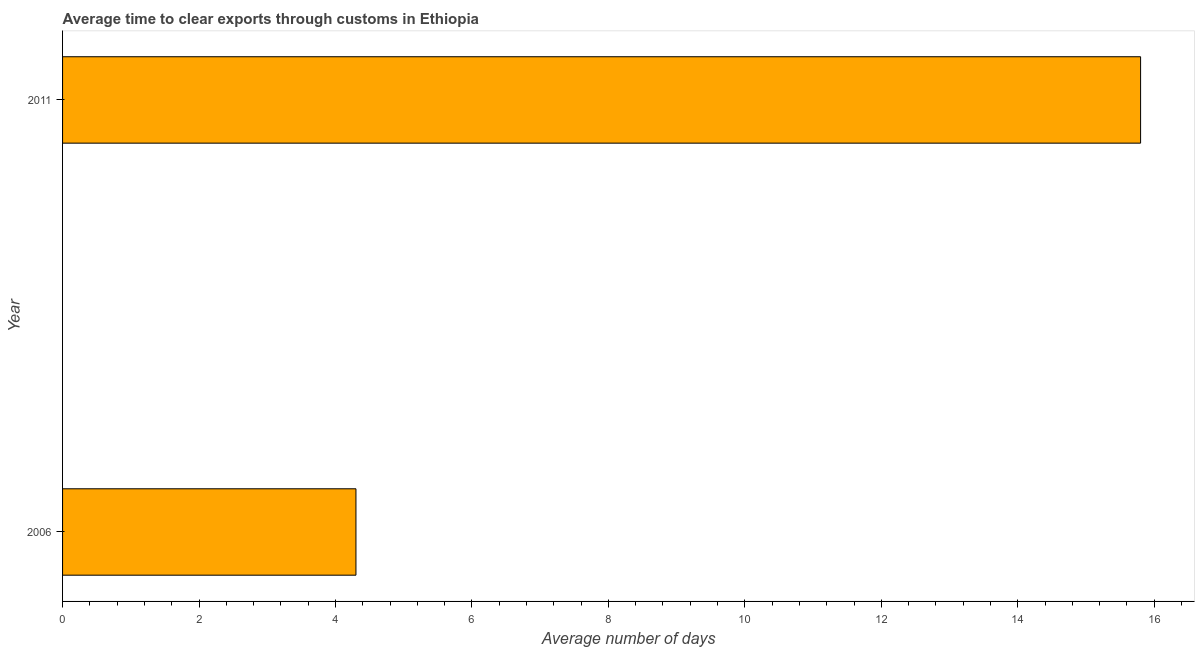Does the graph contain any zero values?
Provide a short and direct response. No. Does the graph contain grids?
Your answer should be compact. No. What is the title of the graph?
Keep it short and to the point. Average time to clear exports through customs in Ethiopia. What is the label or title of the X-axis?
Give a very brief answer. Average number of days. What is the time to clear exports through customs in 2011?
Your answer should be compact. 15.8. Across all years, what is the minimum time to clear exports through customs?
Your answer should be compact. 4.3. In which year was the time to clear exports through customs minimum?
Provide a short and direct response. 2006. What is the sum of the time to clear exports through customs?
Keep it short and to the point. 20.1. What is the difference between the time to clear exports through customs in 2006 and 2011?
Provide a short and direct response. -11.5. What is the average time to clear exports through customs per year?
Offer a terse response. 10.05. What is the median time to clear exports through customs?
Make the answer very short. 10.05. In how many years, is the time to clear exports through customs greater than 9.6 days?
Provide a succinct answer. 1. What is the ratio of the time to clear exports through customs in 2006 to that in 2011?
Provide a short and direct response. 0.27. In how many years, is the time to clear exports through customs greater than the average time to clear exports through customs taken over all years?
Make the answer very short. 1. How many bars are there?
Your answer should be compact. 2. How many years are there in the graph?
Your answer should be compact. 2. What is the difference between two consecutive major ticks on the X-axis?
Offer a very short reply. 2. Are the values on the major ticks of X-axis written in scientific E-notation?
Your answer should be very brief. No. What is the Average number of days of 2006?
Give a very brief answer. 4.3. What is the difference between the Average number of days in 2006 and 2011?
Keep it short and to the point. -11.5. What is the ratio of the Average number of days in 2006 to that in 2011?
Your answer should be compact. 0.27. 